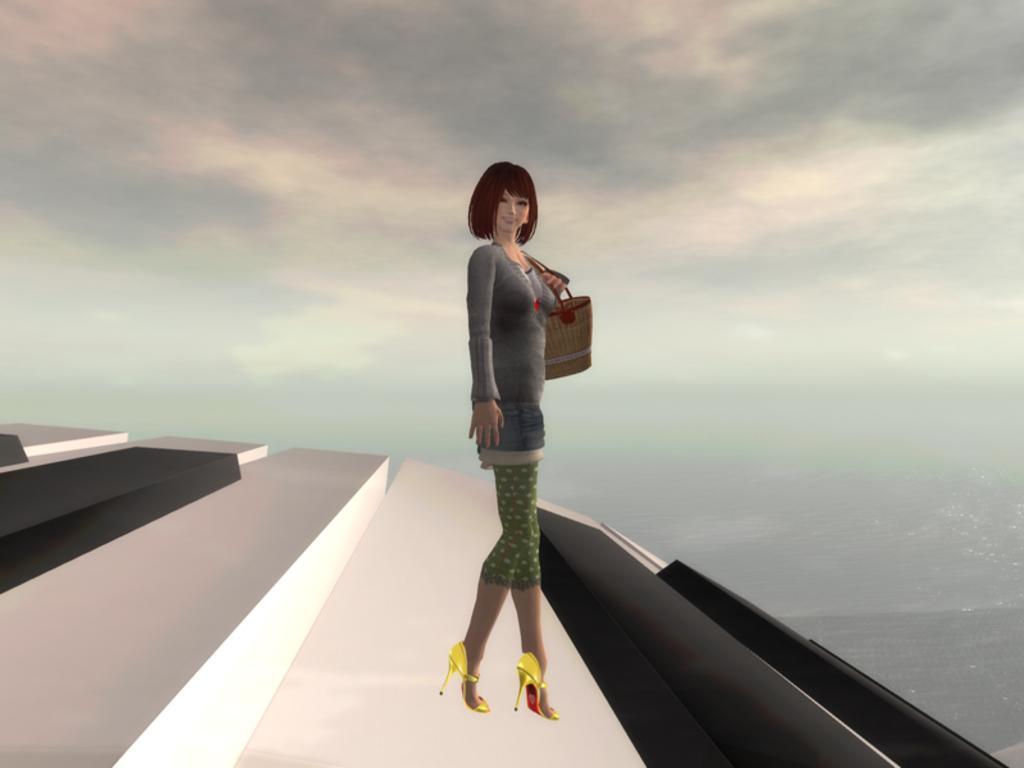Could you give a brief overview of what you see in this image? In this image I can see the digital. I can see a woman wearing grey dress, green pant and yellow foot wear is standing and holding a bag. I can see the white and black colored surface and in the background I can see the sky. 